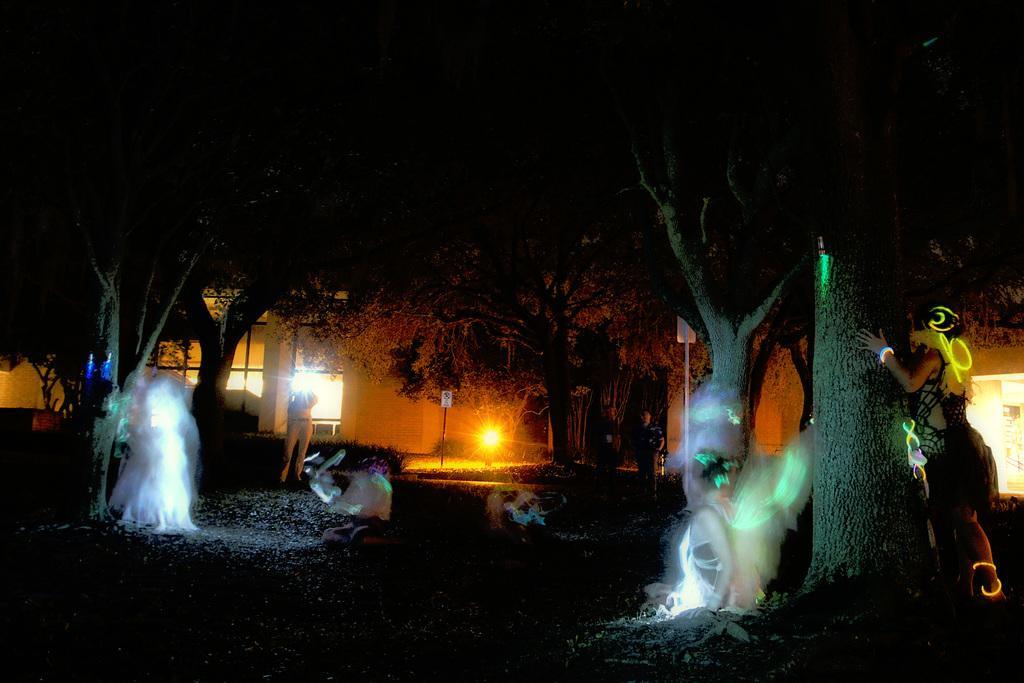How would you summarize this image in a sentence or two? This image is an edited image where the persons are standing and there are trees and there is a building and there is a pole. 